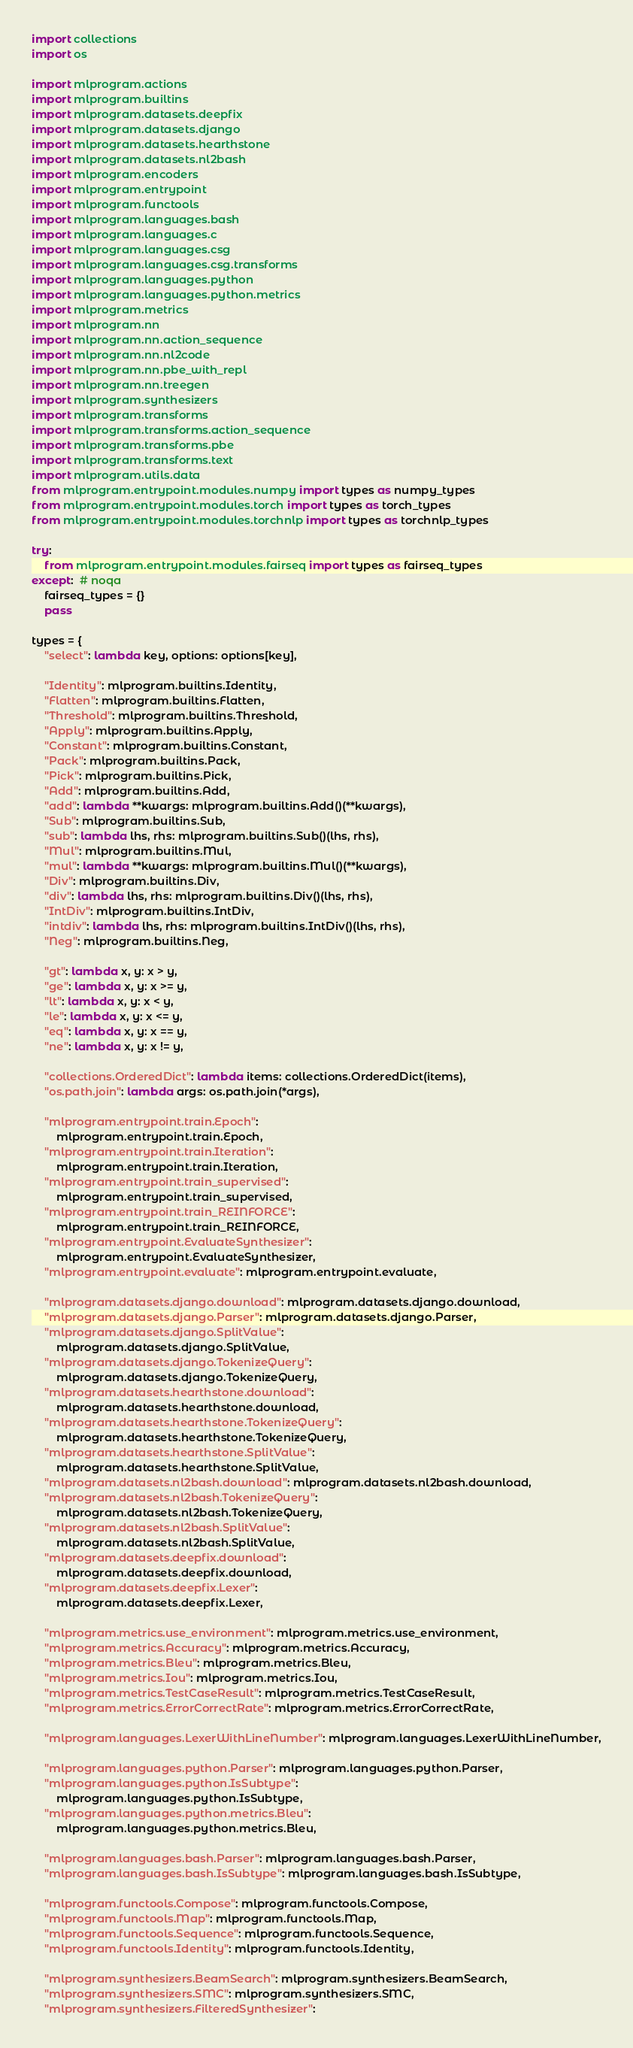Convert code to text. <code><loc_0><loc_0><loc_500><loc_500><_Python_>import collections
import os

import mlprogram.actions
import mlprogram.builtins
import mlprogram.datasets.deepfix
import mlprogram.datasets.django
import mlprogram.datasets.hearthstone
import mlprogram.datasets.nl2bash
import mlprogram.encoders
import mlprogram.entrypoint
import mlprogram.functools
import mlprogram.languages.bash
import mlprogram.languages.c
import mlprogram.languages.csg
import mlprogram.languages.csg.transforms
import mlprogram.languages.python
import mlprogram.languages.python.metrics
import mlprogram.metrics
import mlprogram.nn
import mlprogram.nn.action_sequence
import mlprogram.nn.nl2code
import mlprogram.nn.pbe_with_repl
import mlprogram.nn.treegen
import mlprogram.synthesizers
import mlprogram.transforms
import mlprogram.transforms.action_sequence
import mlprogram.transforms.pbe
import mlprogram.transforms.text
import mlprogram.utils.data
from mlprogram.entrypoint.modules.numpy import types as numpy_types
from mlprogram.entrypoint.modules.torch import types as torch_types
from mlprogram.entrypoint.modules.torchnlp import types as torchnlp_types

try:
    from mlprogram.entrypoint.modules.fairseq import types as fairseq_types
except:  # noqa
    fairseq_types = {}
    pass

types = {
    "select": lambda key, options: options[key],

    "Identity": mlprogram.builtins.Identity,
    "Flatten": mlprogram.builtins.Flatten,
    "Threshold": mlprogram.builtins.Threshold,
    "Apply": mlprogram.builtins.Apply,
    "Constant": mlprogram.builtins.Constant,
    "Pack": mlprogram.builtins.Pack,
    "Pick": mlprogram.builtins.Pick,
    "Add": mlprogram.builtins.Add,
    "add": lambda **kwargs: mlprogram.builtins.Add()(**kwargs),
    "Sub": mlprogram.builtins.Sub,
    "sub": lambda lhs, rhs: mlprogram.builtins.Sub()(lhs, rhs),
    "Mul": mlprogram.builtins.Mul,
    "mul": lambda **kwargs: mlprogram.builtins.Mul()(**kwargs),
    "Div": mlprogram.builtins.Div,
    "div": lambda lhs, rhs: mlprogram.builtins.Div()(lhs, rhs),
    "IntDiv": mlprogram.builtins.IntDiv,
    "intdiv": lambda lhs, rhs: mlprogram.builtins.IntDiv()(lhs, rhs),
    "Neg": mlprogram.builtins.Neg,

    "gt": lambda x, y: x > y,
    "ge": lambda x, y: x >= y,
    "lt": lambda x, y: x < y,
    "le": lambda x, y: x <= y,
    "eq": lambda x, y: x == y,
    "ne": lambda x, y: x != y,

    "collections.OrderedDict": lambda items: collections.OrderedDict(items),
    "os.path.join": lambda args: os.path.join(*args),

    "mlprogram.entrypoint.train.Epoch":
        mlprogram.entrypoint.train.Epoch,
    "mlprogram.entrypoint.train.Iteration":
        mlprogram.entrypoint.train.Iteration,
    "mlprogram.entrypoint.train_supervised":
        mlprogram.entrypoint.train_supervised,
    "mlprogram.entrypoint.train_REINFORCE":
        mlprogram.entrypoint.train_REINFORCE,
    "mlprogram.entrypoint.EvaluateSynthesizer":
        mlprogram.entrypoint.EvaluateSynthesizer,
    "mlprogram.entrypoint.evaluate": mlprogram.entrypoint.evaluate,

    "mlprogram.datasets.django.download": mlprogram.datasets.django.download,
    "mlprogram.datasets.django.Parser": mlprogram.datasets.django.Parser,
    "mlprogram.datasets.django.SplitValue":
        mlprogram.datasets.django.SplitValue,
    "mlprogram.datasets.django.TokenizeQuery":
        mlprogram.datasets.django.TokenizeQuery,
    "mlprogram.datasets.hearthstone.download":
        mlprogram.datasets.hearthstone.download,
    "mlprogram.datasets.hearthstone.TokenizeQuery":
        mlprogram.datasets.hearthstone.TokenizeQuery,
    "mlprogram.datasets.hearthstone.SplitValue":
        mlprogram.datasets.hearthstone.SplitValue,
    "mlprogram.datasets.nl2bash.download": mlprogram.datasets.nl2bash.download,
    "mlprogram.datasets.nl2bash.TokenizeQuery":
        mlprogram.datasets.nl2bash.TokenizeQuery,
    "mlprogram.datasets.nl2bash.SplitValue":
        mlprogram.datasets.nl2bash.SplitValue,
    "mlprogram.datasets.deepfix.download":
        mlprogram.datasets.deepfix.download,
    "mlprogram.datasets.deepfix.Lexer":
        mlprogram.datasets.deepfix.Lexer,

    "mlprogram.metrics.use_environment": mlprogram.metrics.use_environment,
    "mlprogram.metrics.Accuracy": mlprogram.metrics.Accuracy,
    "mlprogram.metrics.Bleu": mlprogram.metrics.Bleu,
    "mlprogram.metrics.Iou": mlprogram.metrics.Iou,
    "mlprogram.metrics.TestCaseResult": mlprogram.metrics.TestCaseResult,
    "mlprogram.metrics.ErrorCorrectRate": mlprogram.metrics.ErrorCorrectRate,

    "mlprogram.languages.LexerWithLineNumber": mlprogram.languages.LexerWithLineNumber,

    "mlprogram.languages.python.Parser": mlprogram.languages.python.Parser,
    "mlprogram.languages.python.IsSubtype":
        mlprogram.languages.python.IsSubtype,
    "mlprogram.languages.python.metrics.Bleu":
        mlprogram.languages.python.metrics.Bleu,

    "mlprogram.languages.bash.Parser": mlprogram.languages.bash.Parser,
    "mlprogram.languages.bash.IsSubtype": mlprogram.languages.bash.IsSubtype,

    "mlprogram.functools.Compose": mlprogram.functools.Compose,
    "mlprogram.functools.Map": mlprogram.functools.Map,
    "mlprogram.functools.Sequence": mlprogram.functools.Sequence,
    "mlprogram.functools.Identity": mlprogram.functools.Identity,

    "mlprogram.synthesizers.BeamSearch": mlprogram.synthesizers.BeamSearch,
    "mlprogram.synthesizers.SMC": mlprogram.synthesizers.SMC,
    "mlprogram.synthesizers.FilteredSynthesizer":</code> 